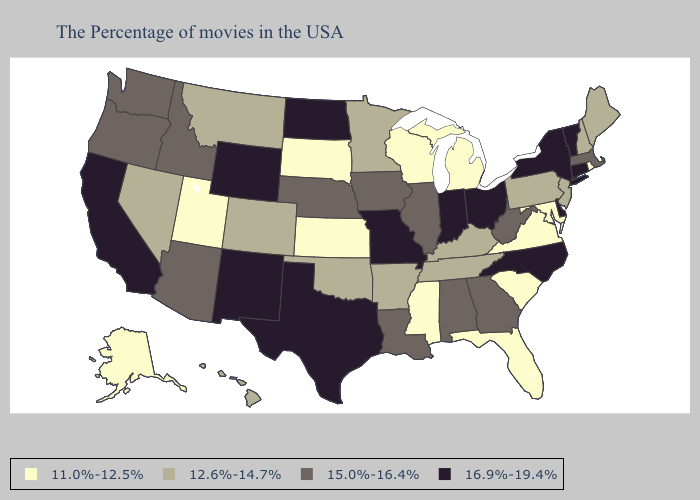Does New York have the lowest value in the Northeast?
Give a very brief answer. No. Does Rhode Island have the lowest value in the Northeast?
Short answer required. Yes. Does Rhode Island have the lowest value in the Northeast?
Keep it brief. Yes. Which states have the lowest value in the South?
Short answer required. Maryland, Virginia, South Carolina, Florida, Mississippi. Which states have the lowest value in the South?
Write a very short answer. Maryland, Virginia, South Carolina, Florida, Mississippi. What is the lowest value in the MidWest?
Concise answer only. 11.0%-12.5%. Does the first symbol in the legend represent the smallest category?
Short answer required. Yes. What is the lowest value in states that border North Dakota?
Answer briefly. 11.0%-12.5%. What is the lowest value in the Northeast?
Give a very brief answer. 11.0%-12.5%. Which states hav the highest value in the MidWest?
Concise answer only. Ohio, Indiana, Missouri, North Dakota. Name the states that have a value in the range 16.9%-19.4%?
Keep it brief. Vermont, Connecticut, New York, Delaware, North Carolina, Ohio, Indiana, Missouri, Texas, North Dakota, Wyoming, New Mexico, California. What is the lowest value in the Northeast?
Short answer required. 11.0%-12.5%. What is the lowest value in the West?
Answer briefly. 11.0%-12.5%. Among the states that border Minnesota , which have the lowest value?
Short answer required. Wisconsin, South Dakota. What is the value of Hawaii?
Write a very short answer. 12.6%-14.7%. 